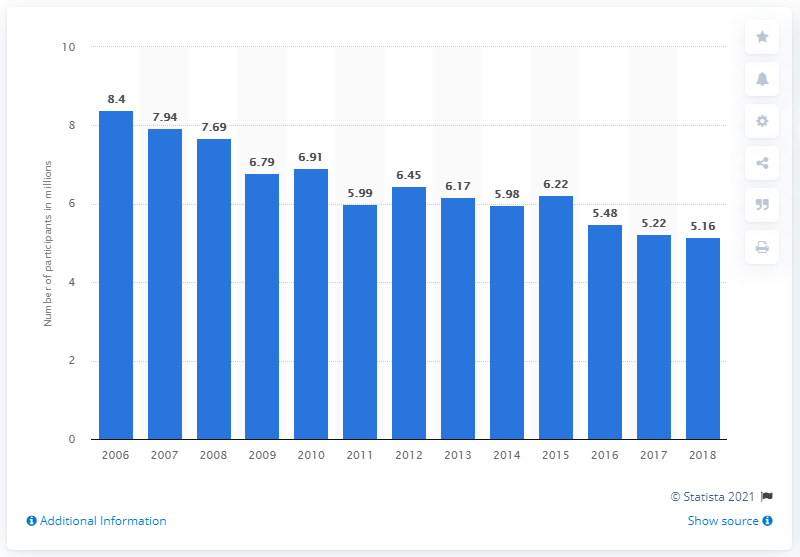Identify some key points in this picture. In 2018, an estimated 5.16 million people aged six and above participated in tackle football in the United States. 